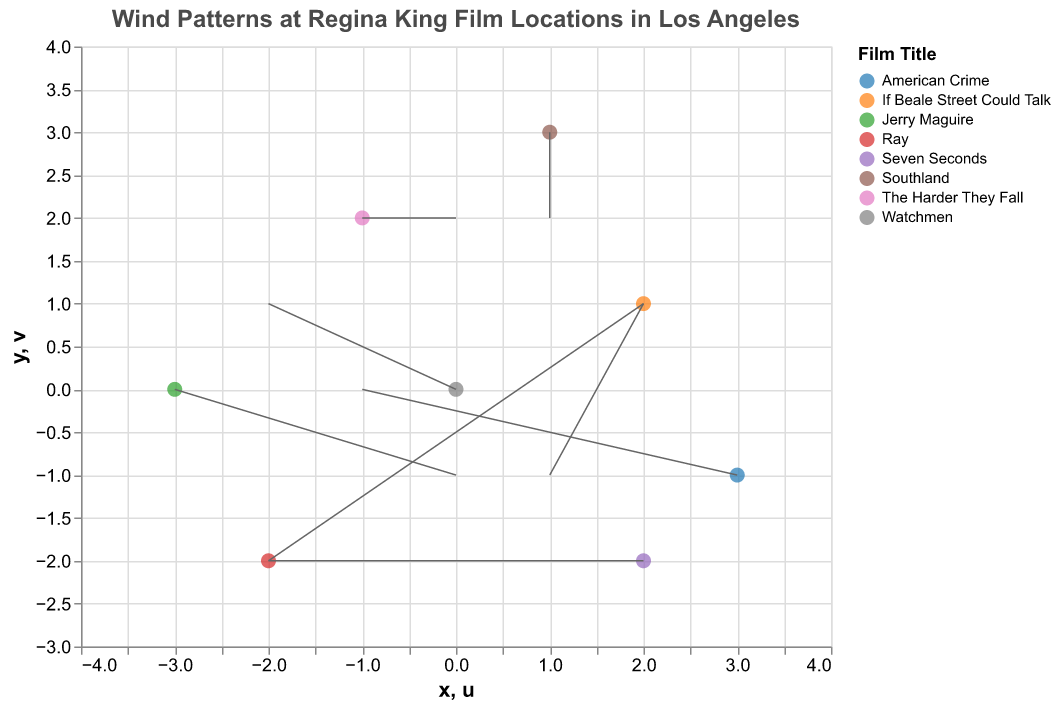What's the title of the plot? The title can be found at the top of the plot in a larger font size and reads "Wind Patterns at Regina King Film Locations in Los Angeles".
Answer: Wind Patterns at Regina King Film Locations in Los Angeles How many data points are plotted in the figure? Counting each unique (x, y) coordinate shows there are 8 data points plotted in the figure.
Answer: 8 Which film location has the strongest upward wind component? The strongest upward wind component is indicated by the longest upward v vector. "Elysian Park" with the film "Southland" has a v of 2, which is the highest value.
Answer: Elysian Park What is the wind pattern at Runyon Canyon? The wind pattern at Runyon Canyon is indicated by its vector (u, v) components. From the data, u = -2 and v = -2, indicating a wind blowing left and downward.
Answer: Left and downward Which wind vector is pointing directly upward and at which location is this occurring? A wind vector pointing directly upward would have a u component of 0 and a positive v component. The data point for "Downtown LA" with the film "The Harder They Fall" has (u = 0, v = 2), which indicates a directly upward wind.
Answer: Downtown LA Compare the wind directions at Griffith Park and Santa Monica Pier. Which location has a more favorable condition for shooting if we want less interference from the wind? Griffith Park's wind vector is (-2, 1), while Santa Monica Pier's wind vector is (2, 1). In terms of minimizing wind interference, both locations have similar upward wind components (v = 1), but Griffith Park’s vector points towards the left and Santa Monica Pier's to the right. For side-wise minimization, it depends on shooting preferences, but overall both have similar conditions.
Answer: Similar conditions Which location has a significant downward wind and how can it affect film production? The significant downward wind occurs at Sepulveda Dam with the vector (u = 0, v = -1). This downward wind might affect filming by possibly causing dust or vertical motion that could get into camera shots.
Answer: Sepulveda Dam What is the general wind trend observed at Elysian Park, and does it favor outdoor shooting? Elysian Park shows a wind vector of (u = 1, v = 2), indicating wind blowing to the right and strongly upward. Such an upward wind might carry debris and affect boom mics or lightweight equipment adversely. It generally does not favor outdoor shooting.
Answer: No How many locations have wind components affecting the y-axis negatively? Name them. Checking for negative v components shows two locations: Runyon Canyon (v = -2) and Sepulveda Dam (v = -1).
Answer: Runyon Canyon, Sepulveda Dam 